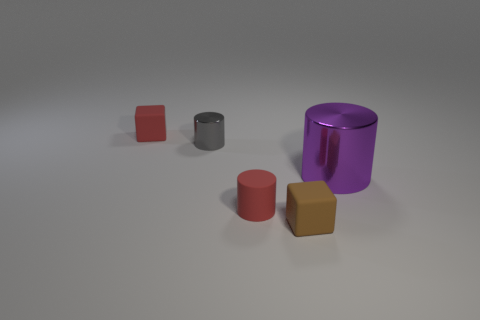Is there anything else that is the same size as the purple cylinder?
Give a very brief answer. No. Do the gray cylinder and the small brown cube have the same material?
Your response must be concise. No. There is a cylinder that is on the left side of the large purple cylinder and in front of the tiny gray metal cylinder; what size is it?
Offer a very short reply. Small. What number of other brown cubes are the same size as the brown rubber cube?
Your answer should be very brief. 0. What size is the rubber block on the right side of the red matte object that is behind the purple metallic thing?
Offer a very short reply. Small. Do the metallic object behind the large metal thing and the small rubber object that is behind the purple cylinder have the same shape?
Keep it short and to the point. No. What color is the thing that is left of the tiny rubber cylinder and in front of the small red block?
Ensure brevity in your answer.  Gray. Are there any cubes of the same color as the matte cylinder?
Your response must be concise. Yes. What color is the rubber block that is in front of the big thing?
Provide a succinct answer. Brown. Is there a tiny brown cube right of the cube right of the small red rubber block?
Offer a very short reply. No. 